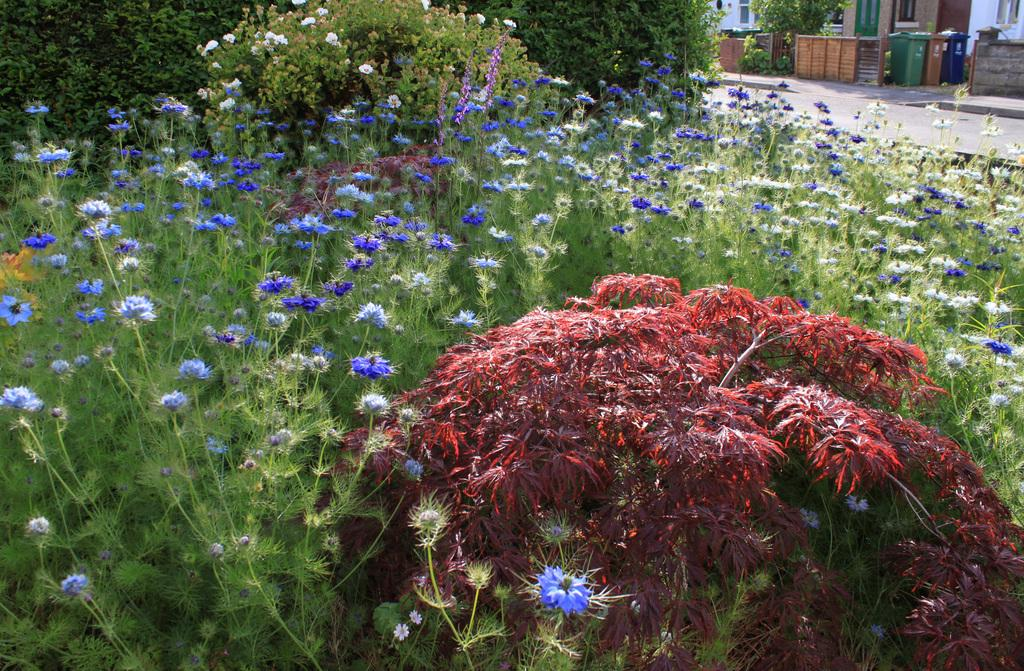What type of vegetation can be seen in the image? There are plants and flowers in the image. What else can be seen in the background of the image? There are bushes and buildings in the background of the image. What objects are present for waste disposal in the image? There are bins in the image. What language is spoken by the plants in the image? Plants do not speak any language, so this cannot be determined from the image. 